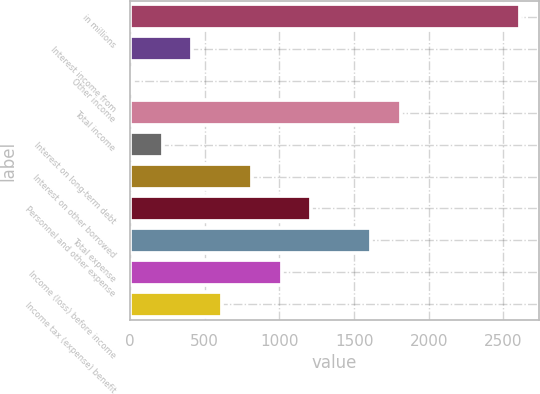Convert chart. <chart><loc_0><loc_0><loc_500><loc_500><bar_chart><fcel>in millions<fcel>Interest income from<fcel>Other income<fcel>Total income<fcel>Interest on long-term debt<fcel>Interest on other borrowed<fcel>Personnel and other expense<fcel>Total expense<fcel>Income (loss) before income<fcel>Income tax (expense) benefit<nl><fcel>2608.9<fcel>416.6<fcel>18<fcel>1811.7<fcel>217.3<fcel>815.2<fcel>1213.8<fcel>1612.4<fcel>1014.5<fcel>615.9<nl></chart> 